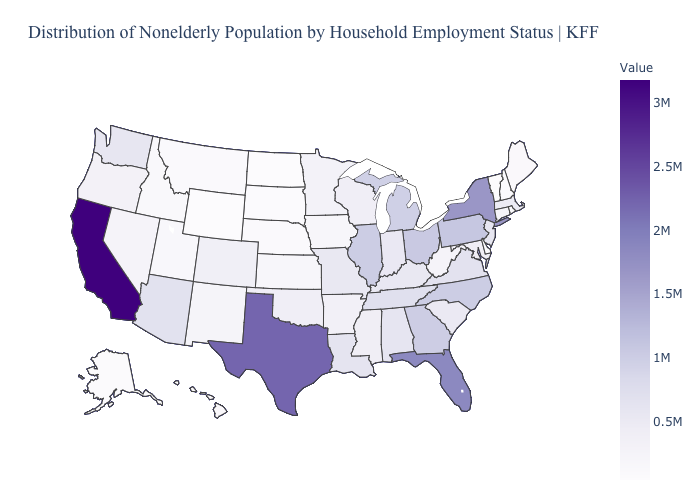Does the map have missing data?
Quick response, please. No. Which states have the lowest value in the USA?
Answer briefly. Wyoming. Which states have the lowest value in the USA?
Be succinct. Wyoming. Which states have the lowest value in the MidWest?
Quick response, please. North Dakota. 